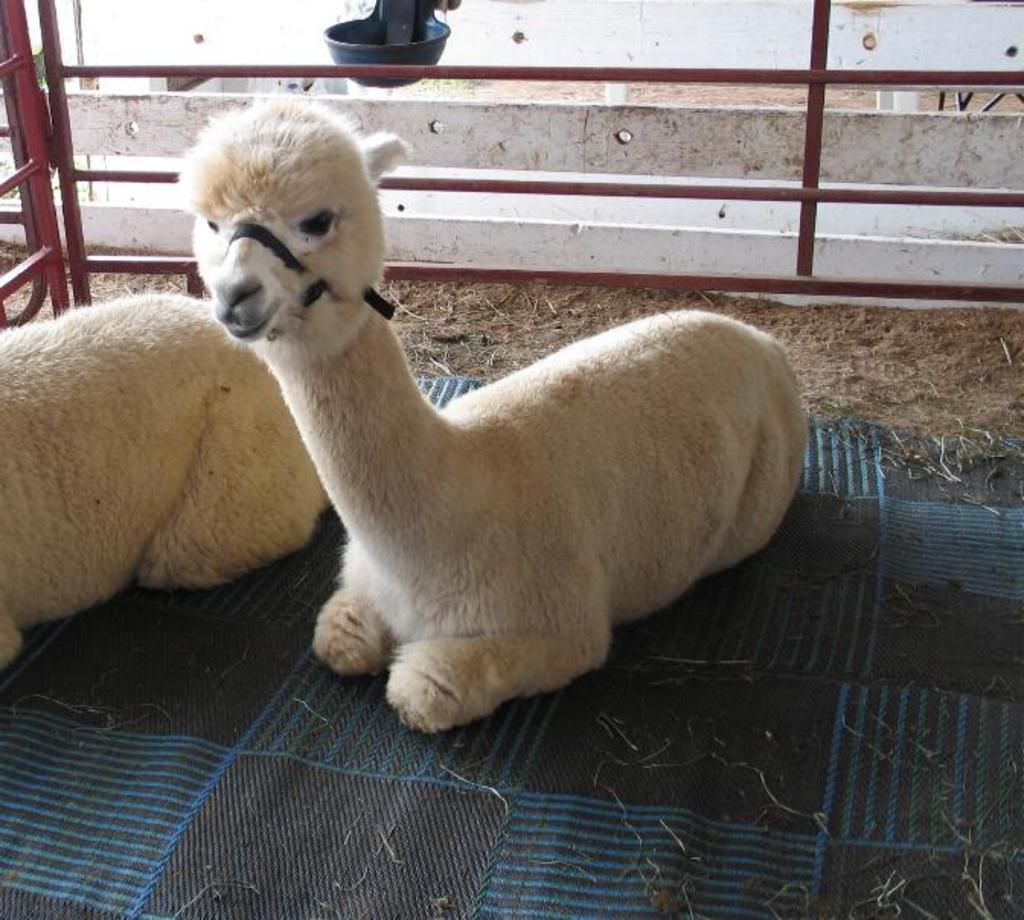What is the main subject of the image? The main subject of the image is animals on a cloth. What can be seen in the background of the image? There is a fence visible in the image. What other object is present in the image? There is a bowl in the image. What type of footwear is visible on the animals in the image? There is no footwear visible on the animals in the image, as they are not wearing any. 